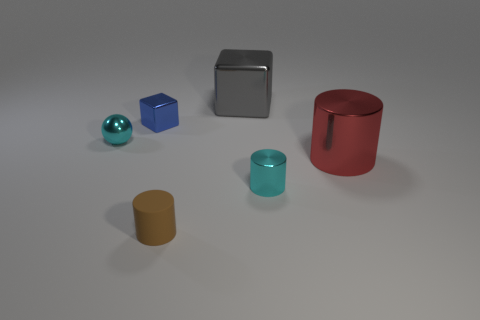Add 1 cyan metallic things. How many objects exist? 7 Subtract all large red metal cylinders. How many cylinders are left? 2 Subtract all cubes. How many objects are left? 4 Add 3 small blue blocks. How many small blue blocks are left? 4 Add 1 green blocks. How many green blocks exist? 1 Subtract all red cylinders. How many cylinders are left? 2 Subtract 0 green blocks. How many objects are left? 6 Subtract 1 balls. How many balls are left? 0 Subtract all blue spheres. Subtract all purple cylinders. How many spheres are left? 1 Subtract all small cylinders. Subtract all small cyan metal cylinders. How many objects are left? 3 